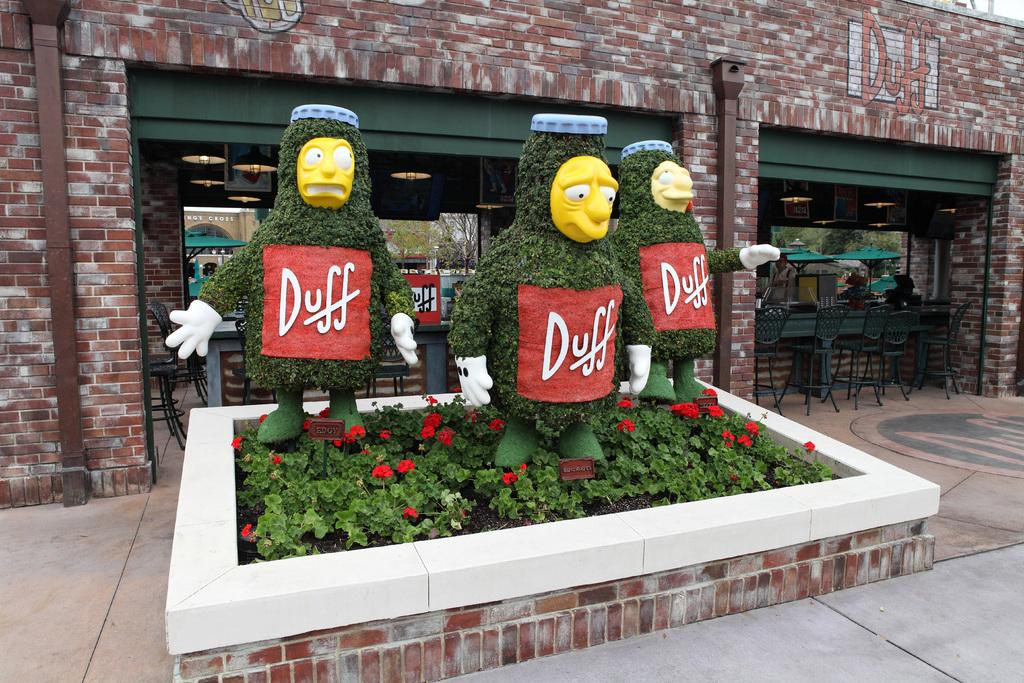<image>
Relay a brief, clear account of the picture shown. Several lawn bushes are cut out and have red Duff signs on them. 